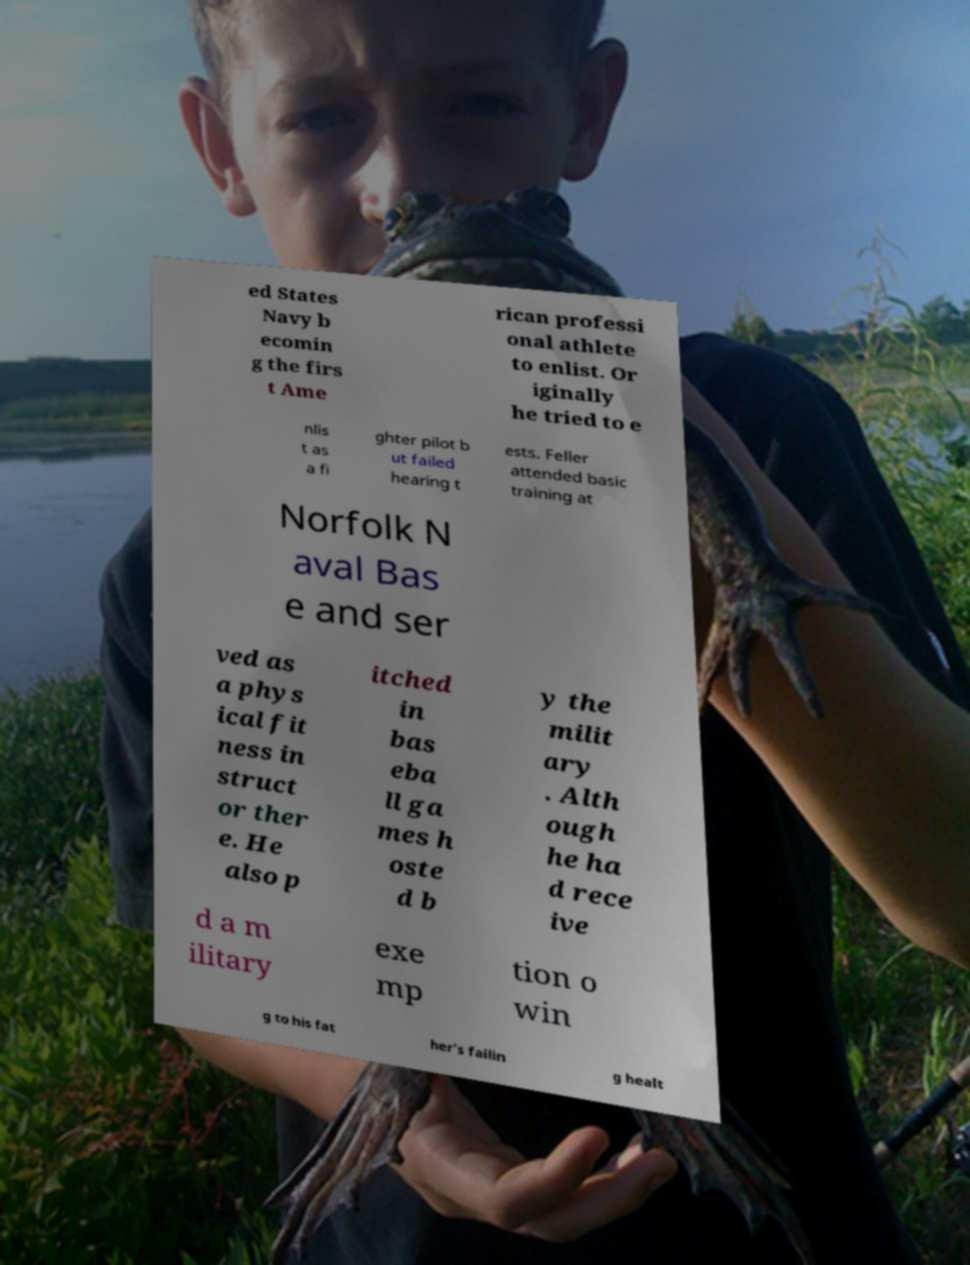There's text embedded in this image that I need extracted. Can you transcribe it verbatim? ed States Navy b ecomin g the firs t Ame rican professi onal athlete to enlist. Or iginally he tried to e nlis t as a fi ghter pilot b ut failed hearing t ests. Feller attended basic training at Norfolk N aval Bas e and ser ved as a phys ical fit ness in struct or ther e. He also p itched in bas eba ll ga mes h oste d b y the milit ary . Alth ough he ha d rece ive d a m ilitary exe mp tion o win g to his fat her's failin g healt 